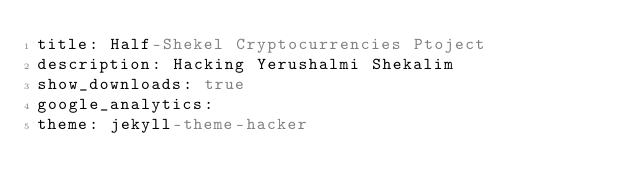<code> <loc_0><loc_0><loc_500><loc_500><_YAML_>title: Half-Shekel Cryptocurrencies Ptoject
description: Hacking Yerushalmi Shekalim
show_downloads: true
google_analytics:
theme: jekyll-theme-hacker
</code> 